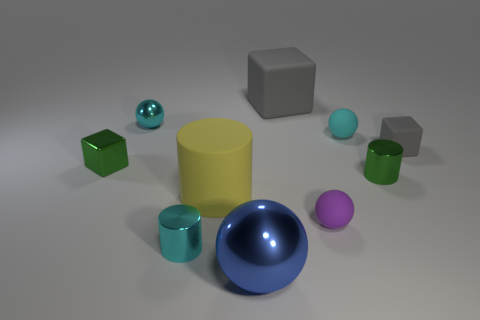Which object stands out the most due to its size? The yellow cylinder stands out the most due to its size as it is the tallest object in the scene. Can you describe the material textures that are visible in the image? The objects have a variety of material textures. The spheres and the cylinders exhibit a shiny, reflective surface, indicative of a metallic or polished finish, while the cubes and blocks have a matte finish, suggesting a rubber or a plastic material. 